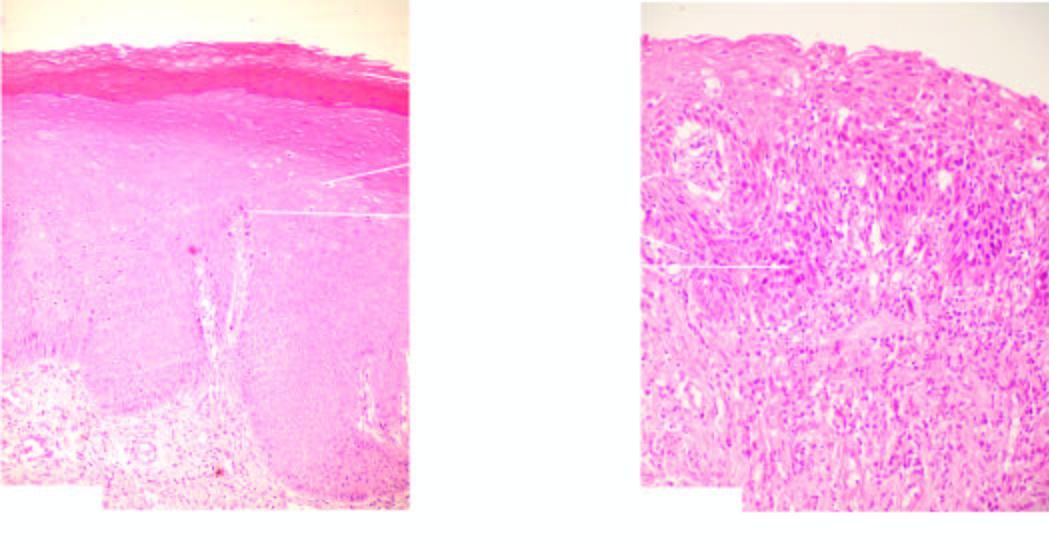s there no invasion across the basement membrane?
Answer the question using a single word or phrase. Yes 